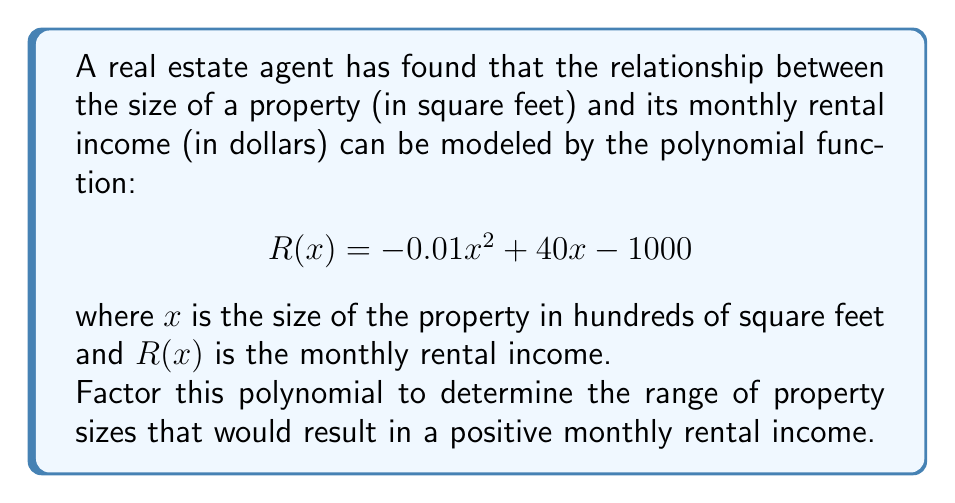Can you answer this question? To solve this problem, we need to factor the given polynomial and find its roots. The steps are as follows:

1) The polynomial is in the form $ax^2 + bx + c$, where:
   $a = -0.01$
   $b = 40$
   $c = -1000$

2) We can factor this using the quadratic formula: $x = \frac{-b \pm \sqrt{b^2 - 4ac}}{2a}$

3) Substituting our values:
   $$x = \frac{-40 \pm \sqrt{40^2 - 4(-0.01)(-1000)}}{2(-0.01)}$$

4) Simplifying:
   $$x = \frac{-40 \pm \sqrt{1600 - 40}}{-0.02} = \frac{-40 \pm \sqrt{1560}}{-0.02}$$

5) $\sqrt{1560} \approx 39.50$, so:
   $$x = \frac{-40 \pm 39.50}{-0.02}$$

6) This gives us two solutions:
   $$x_1 = \frac{-40 + 39.50}{-0.02} \approx 25$$
   $$x_2 = \frac{-40 - 39.50}{-0.02} \approx 3975$$

7) Therefore, the factored form of the polynomial is:
   $$R(x) = -0.01(x - 25)(x - 3975)$$

8) The rental income will be positive when $R(x) > 0$. This occurs when:
   $(x - 25) < 0$ and $(x - 3975) < 0$, or
   $(x - 25) > 0$ and $(x - 3975) > 0$

9) Solving these inequalities:
   $25 < x < 3975$

This means the rental income is positive for property sizes between 2,500 and 397,500 square feet.
Answer: $R(x) = -0.01(x - 25)(x - 3975)$; positive rental income for $2,500 < x < 397,500$ sq ft 